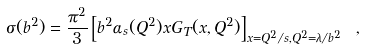<formula> <loc_0><loc_0><loc_500><loc_500>\sigma ( b ^ { 2 } ) = { \frac { \pi ^ { 2 } } { 3 } } \left [ b ^ { 2 } \alpha _ { s } ( Q ^ { 2 } ) x G _ { T } ( x , Q ^ { 2 } ) \right ] _ { x = Q ^ { 2 } / s , Q ^ { 2 } = \lambda / b ^ { 2 } } \ ,</formula> 